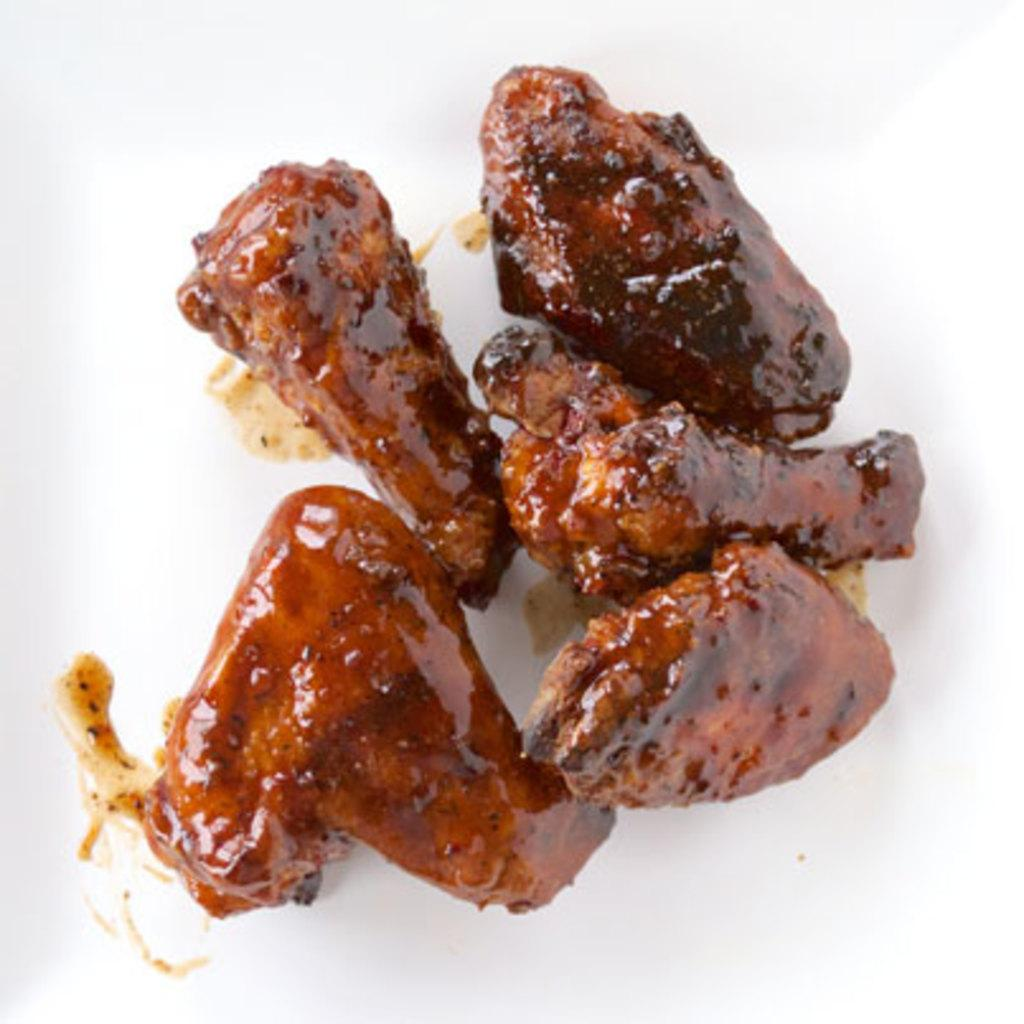What type of food items can be seen in the image? The food items resemble meat slices. What action is the food item performing in the image? The food items are not performing any action in the image, as they are inanimate objects. 